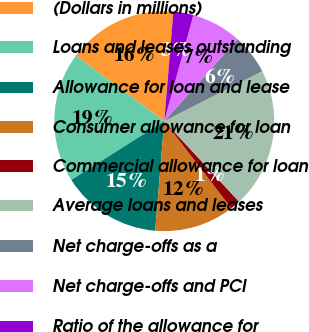<chart> <loc_0><loc_0><loc_500><loc_500><pie_chart><fcel>(Dollars in millions)<fcel>Loans and leases outstanding<fcel>Allowance for loan and lease<fcel>Consumer allowance for loan<fcel>Commercial allowance for loan<fcel>Average loans and leases<fcel>Net charge-offs as a<fcel>Net charge-offs and PCI<fcel>Ratio of the allowance for<nl><fcel>16.18%<fcel>19.12%<fcel>14.71%<fcel>11.76%<fcel>1.47%<fcel>20.59%<fcel>5.88%<fcel>7.35%<fcel>2.94%<nl></chart> 